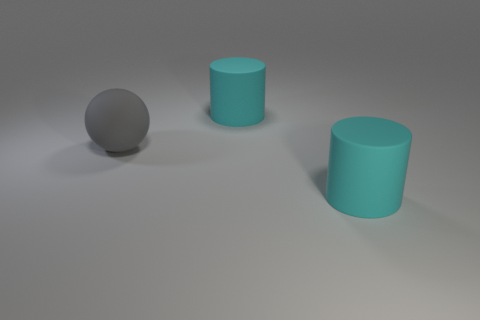How big is the object that is on the right side of the cyan cylinder behind the cyan object in front of the big gray rubber sphere?
Provide a short and direct response. Large. How many other things are there of the same shape as the gray object?
Offer a terse response. 0. Do the large matte cylinder behind the large gray ball and the large matte cylinder in front of the gray sphere have the same color?
Make the answer very short. Yes. Does the cyan cylinder behind the gray matte ball have the same size as the rubber ball?
Give a very brief answer. Yes. Are there the same number of gray spheres behind the gray matte sphere and gray matte objects?
Your answer should be very brief. No. How many objects are large cylinders that are in front of the big gray matte sphere or small red matte cylinders?
Your answer should be very brief. 1. What number of things are either large cyan things that are in front of the gray sphere or large cyan matte things behind the gray matte object?
Keep it short and to the point. 2. How many other things are the same size as the gray matte sphere?
Your answer should be very brief. 2. How many tiny objects are cylinders or rubber things?
Provide a short and direct response. 0. There is a cyan matte object that is behind the large matte ball; what is its shape?
Provide a short and direct response. Cylinder. 